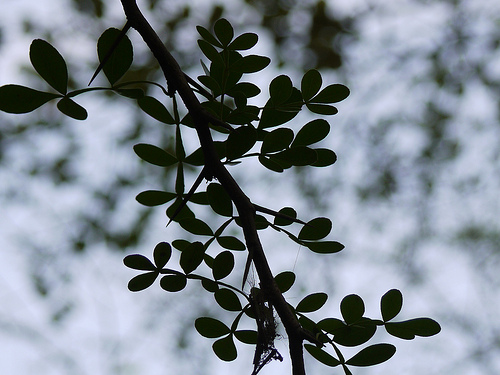<image>
Is there a leaf in the branch? No. The leaf is not contained within the branch. These objects have a different spatial relationship. 